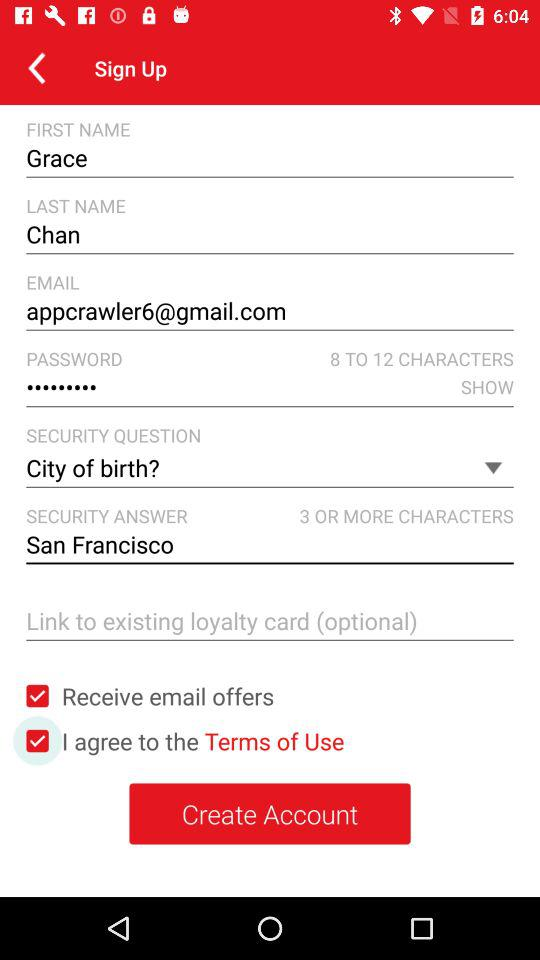What is the email address? The email address is appcrawler6@gmail.com. 